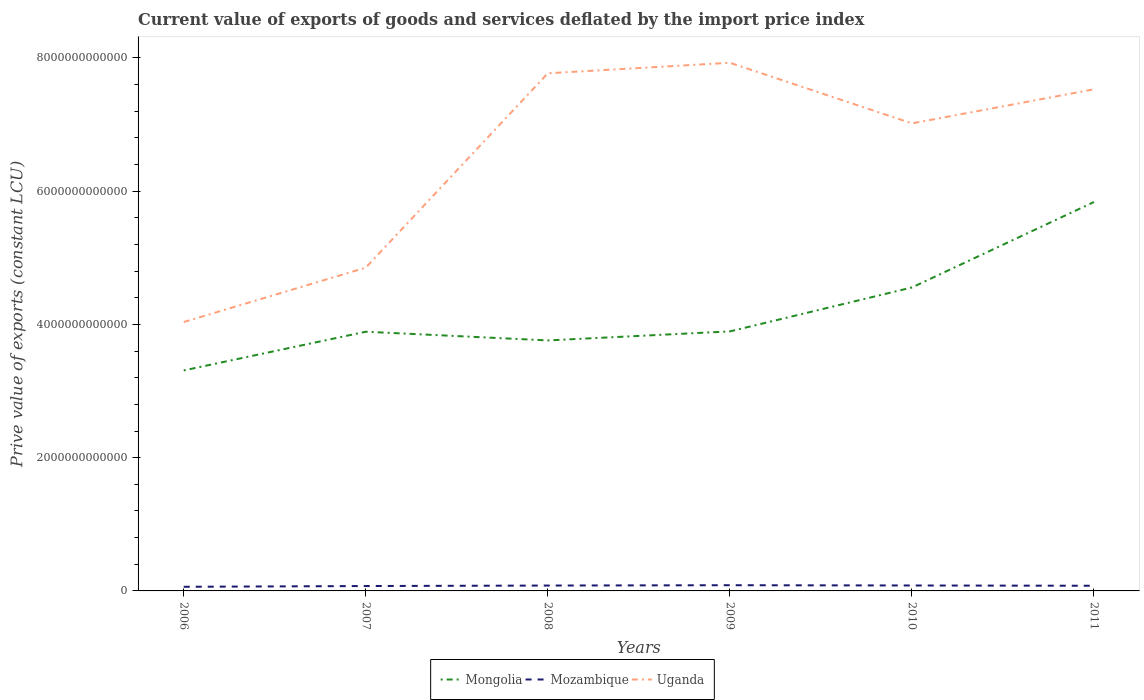Is the number of lines equal to the number of legend labels?
Make the answer very short. Yes. Across all years, what is the maximum prive value of exports in Mozambique?
Make the answer very short. 6.20e+1. What is the total prive value of exports in Mongolia in the graph?
Your answer should be compact. -1.25e+12. What is the difference between the highest and the second highest prive value of exports in Mozambique?
Offer a very short reply. 2.36e+1. What is the difference between the highest and the lowest prive value of exports in Uganda?
Your response must be concise. 4. How many years are there in the graph?
Your answer should be compact. 6. What is the difference between two consecutive major ticks on the Y-axis?
Your answer should be compact. 2.00e+12. How many legend labels are there?
Make the answer very short. 3. How are the legend labels stacked?
Ensure brevity in your answer.  Horizontal. What is the title of the graph?
Give a very brief answer. Current value of exports of goods and services deflated by the import price index. Does "Oman" appear as one of the legend labels in the graph?
Give a very brief answer. No. What is the label or title of the Y-axis?
Offer a terse response. Prive value of exports (constant LCU). What is the Prive value of exports (constant LCU) in Mongolia in 2006?
Make the answer very short. 3.31e+12. What is the Prive value of exports (constant LCU) in Mozambique in 2006?
Provide a succinct answer. 6.20e+1. What is the Prive value of exports (constant LCU) in Uganda in 2006?
Give a very brief answer. 4.04e+12. What is the Prive value of exports (constant LCU) of Mongolia in 2007?
Make the answer very short. 3.89e+12. What is the Prive value of exports (constant LCU) of Mozambique in 2007?
Your answer should be compact. 7.33e+1. What is the Prive value of exports (constant LCU) of Uganda in 2007?
Offer a terse response. 4.85e+12. What is the Prive value of exports (constant LCU) in Mongolia in 2008?
Give a very brief answer. 3.76e+12. What is the Prive value of exports (constant LCU) of Mozambique in 2008?
Make the answer very short. 8.07e+1. What is the Prive value of exports (constant LCU) in Uganda in 2008?
Your answer should be compact. 7.77e+12. What is the Prive value of exports (constant LCU) of Mongolia in 2009?
Your answer should be very brief. 3.89e+12. What is the Prive value of exports (constant LCU) in Mozambique in 2009?
Give a very brief answer. 8.57e+1. What is the Prive value of exports (constant LCU) of Uganda in 2009?
Provide a succinct answer. 7.93e+12. What is the Prive value of exports (constant LCU) in Mongolia in 2010?
Offer a terse response. 4.55e+12. What is the Prive value of exports (constant LCU) in Mozambique in 2010?
Keep it short and to the point. 8.16e+1. What is the Prive value of exports (constant LCU) of Uganda in 2010?
Make the answer very short. 7.02e+12. What is the Prive value of exports (constant LCU) of Mongolia in 2011?
Ensure brevity in your answer.  5.84e+12. What is the Prive value of exports (constant LCU) of Mozambique in 2011?
Provide a short and direct response. 7.76e+1. What is the Prive value of exports (constant LCU) of Uganda in 2011?
Your response must be concise. 7.53e+12. Across all years, what is the maximum Prive value of exports (constant LCU) of Mongolia?
Give a very brief answer. 5.84e+12. Across all years, what is the maximum Prive value of exports (constant LCU) in Mozambique?
Offer a very short reply. 8.57e+1. Across all years, what is the maximum Prive value of exports (constant LCU) of Uganda?
Keep it short and to the point. 7.93e+12. Across all years, what is the minimum Prive value of exports (constant LCU) in Mongolia?
Offer a very short reply. 3.31e+12. Across all years, what is the minimum Prive value of exports (constant LCU) in Mozambique?
Make the answer very short. 6.20e+1. Across all years, what is the minimum Prive value of exports (constant LCU) of Uganda?
Offer a terse response. 4.04e+12. What is the total Prive value of exports (constant LCU) of Mongolia in the graph?
Ensure brevity in your answer.  2.52e+13. What is the total Prive value of exports (constant LCU) in Mozambique in the graph?
Your response must be concise. 4.61e+11. What is the total Prive value of exports (constant LCU) in Uganda in the graph?
Your answer should be very brief. 3.91e+13. What is the difference between the Prive value of exports (constant LCU) in Mongolia in 2006 and that in 2007?
Keep it short and to the point. -5.81e+11. What is the difference between the Prive value of exports (constant LCU) of Mozambique in 2006 and that in 2007?
Offer a terse response. -1.13e+1. What is the difference between the Prive value of exports (constant LCU) in Uganda in 2006 and that in 2007?
Provide a short and direct response. -8.16e+11. What is the difference between the Prive value of exports (constant LCU) of Mongolia in 2006 and that in 2008?
Give a very brief answer. -4.50e+11. What is the difference between the Prive value of exports (constant LCU) of Mozambique in 2006 and that in 2008?
Make the answer very short. -1.87e+1. What is the difference between the Prive value of exports (constant LCU) of Uganda in 2006 and that in 2008?
Offer a terse response. -3.73e+12. What is the difference between the Prive value of exports (constant LCU) of Mongolia in 2006 and that in 2009?
Offer a terse response. -5.86e+11. What is the difference between the Prive value of exports (constant LCU) in Mozambique in 2006 and that in 2009?
Give a very brief answer. -2.36e+1. What is the difference between the Prive value of exports (constant LCU) in Uganda in 2006 and that in 2009?
Provide a succinct answer. -3.89e+12. What is the difference between the Prive value of exports (constant LCU) in Mongolia in 2006 and that in 2010?
Your answer should be compact. -1.25e+12. What is the difference between the Prive value of exports (constant LCU) in Mozambique in 2006 and that in 2010?
Make the answer very short. -1.96e+1. What is the difference between the Prive value of exports (constant LCU) of Uganda in 2006 and that in 2010?
Ensure brevity in your answer.  -2.98e+12. What is the difference between the Prive value of exports (constant LCU) of Mongolia in 2006 and that in 2011?
Your response must be concise. -2.53e+12. What is the difference between the Prive value of exports (constant LCU) in Mozambique in 2006 and that in 2011?
Give a very brief answer. -1.55e+1. What is the difference between the Prive value of exports (constant LCU) of Uganda in 2006 and that in 2011?
Ensure brevity in your answer.  -3.49e+12. What is the difference between the Prive value of exports (constant LCU) in Mongolia in 2007 and that in 2008?
Provide a succinct answer. 1.30e+11. What is the difference between the Prive value of exports (constant LCU) in Mozambique in 2007 and that in 2008?
Your answer should be very brief. -7.39e+09. What is the difference between the Prive value of exports (constant LCU) of Uganda in 2007 and that in 2008?
Your answer should be very brief. -2.92e+12. What is the difference between the Prive value of exports (constant LCU) of Mongolia in 2007 and that in 2009?
Provide a succinct answer. -4.92e+09. What is the difference between the Prive value of exports (constant LCU) in Mozambique in 2007 and that in 2009?
Provide a short and direct response. -1.24e+1. What is the difference between the Prive value of exports (constant LCU) of Uganda in 2007 and that in 2009?
Provide a succinct answer. -3.07e+12. What is the difference between the Prive value of exports (constant LCU) in Mongolia in 2007 and that in 2010?
Your answer should be very brief. -6.64e+11. What is the difference between the Prive value of exports (constant LCU) of Mozambique in 2007 and that in 2010?
Give a very brief answer. -8.29e+09. What is the difference between the Prive value of exports (constant LCU) in Uganda in 2007 and that in 2010?
Ensure brevity in your answer.  -2.17e+12. What is the difference between the Prive value of exports (constant LCU) in Mongolia in 2007 and that in 2011?
Give a very brief answer. -1.95e+12. What is the difference between the Prive value of exports (constant LCU) in Mozambique in 2007 and that in 2011?
Ensure brevity in your answer.  -4.24e+09. What is the difference between the Prive value of exports (constant LCU) of Uganda in 2007 and that in 2011?
Make the answer very short. -2.68e+12. What is the difference between the Prive value of exports (constant LCU) of Mongolia in 2008 and that in 2009?
Provide a succinct answer. -1.35e+11. What is the difference between the Prive value of exports (constant LCU) in Mozambique in 2008 and that in 2009?
Keep it short and to the point. -4.97e+09. What is the difference between the Prive value of exports (constant LCU) of Uganda in 2008 and that in 2009?
Make the answer very short. -1.58e+11. What is the difference between the Prive value of exports (constant LCU) in Mongolia in 2008 and that in 2010?
Provide a succinct answer. -7.95e+11. What is the difference between the Prive value of exports (constant LCU) of Mozambique in 2008 and that in 2010?
Your response must be concise. -9.01e+08. What is the difference between the Prive value of exports (constant LCU) in Uganda in 2008 and that in 2010?
Provide a succinct answer. 7.52e+11. What is the difference between the Prive value of exports (constant LCU) in Mongolia in 2008 and that in 2011?
Your response must be concise. -2.08e+12. What is the difference between the Prive value of exports (constant LCU) in Mozambique in 2008 and that in 2011?
Keep it short and to the point. 3.14e+09. What is the difference between the Prive value of exports (constant LCU) of Uganda in 2008 and that in 2011?
Give a very brief answer. 2.40e+11. What is the difference between the Prive value of exports (constant LCU) of Mongolia in 2009 and that in 2010?
Your response must be concise. -6.59e+11. What is the difference between the Prive value of exports (constant LCU) in Mozambique in 2009 and that in 2010?
Your response must be concise. 4.07e+09. What is the difference between the Prive value of exports (constant LCU) of Uganda in 2009 and that in 2010?
Provide a succinct answer. 9.10e+11. What is the difference between the Prive value of exports (constant LCU) of Mongolia in 2009 and that in 2011?
Offer a terse response. -1.94e+12. What is the difference between the Prive value of exports (constant LCU) in Mozambique in 2009 and that in 2011?
Your answer should be compact. 8.12e+09. What is the difference between the Prive value of exports (constant LCU) of Uganda in 2009 and that in 2011?
Your response must be concise. 3.98e+11. What is the difference between the Prive value of exports (constant LCU) of Mongolia in 2010 and that in 2011?
Provide a succinct answer. -1.28e+12. What is the difference between the Prive value of exports (constant LCU) in Mozambique in 2010 and that in 2011?
Keep it short and to the point. 4.04e+09. What is the difference between the Prive value of exports (constant LCU) of Uganda in 2010 and that in 2011?
Make the answer very short. -5.12e+11. What is the difference between the Prive value of exports (constant LCU) of Mongolia in 2006 and the Prive value of exports (constant LCU) of Mozambique in 2007?
Keep it short and to the point. 3.24e+12. What is the difference between the Prive value of exports (constant LCU) in Mongolia in 2006 and the Prive value of exports (constant LCU) in Uganda in 2007?
Make the answer very short. -1.54e+12. What is the difference between the Prive value of exports (constant LCU) in Mozambique in 2006 and the Prive value of exports (constant LCU) in Uganda in 2007?
Make the answer very short. -4.79e+12. What is the difference between the Prive value of exports (constant LCU) in Mongolia in 2006 and the Prive value of exports (constant LCU) in Mozambique in 2008?
Offer a very short reply. 3.23e+12. What is the difference between the Prive value of exports (constant LCU) in Mongolia in 2006 and the Prive value of exports (constant LCU) in Uganda in 2008?
Your answer should be very brief. -4.46e+12. What is the difference between the Prive value of exports (constant LCU) in Mozambique in 2006 and the Prive value of exports (constant LCU) in Uganda in 2008?
Your answer should be very brief. -7.71e+12. What is the difference between the Prive value of exports (constant LCU) in Mongolia in 2006 and the Prive value of exports (constant LCU) in Mozambique in 2009?
Make the answer very short. 3.22e+12. What is the difference between the Prive value of exports (constant LCU) in Mongolia in 2006 and the Prive value of exports (constant LCU) in Uganda in 2009?
Ensure brevity in your answer.  -4.62e+12. What is the difference between the Prive value of exports (constant LCU) in Mozambique in 2006 and the Prive value of exports (constant LCU) in Uganda in 2009?
Provide a short and direct response. -7.86e+12. What is the difference between the Prive value of exports (constant LCU) in Mongolia in 2006 and the Prive value of exports (constant LCU) in Mozambique in 2010?
Ensure brevity in your answer.  3.23e+12. What is the difference between the Prive value of exports (constant LCU) of Mongolia in 2006 and the Prive value of exports (constant LCU) of Uganda in 2010?
Keep it short and to the point. -3.71e+12. What is the difference between the Prive value of exports (constant LCU) in Mozambique in 2006 and the Prive value of exports (constant LCU) in Uganda in 2010?
Your answer should be very brief. -6.95e+12. What is the difference between the Prive value of exports (constant LCU) in Mongolia in 2006 and the Prive value of exports (constant LCU) in Mozambique in 2011?
Offer a terse response. 3.23e+12. What is the difference between the Prive value of exports (constant LCU) of Mongolia in 2006 and the Prive value of exports (constant LCU) of Uganda in 2011?
Your answer should be compact. -4.22e+12. What is the difference between the Prive value of exports (constant LCU) in Mozambique in 2006 and the Prive value of exports (constant LCU) in Uganda in 2011?
Provide a succinct answer. -7.47e+12. What is the difference between the Prive value of exports (constant LCU) in Mongolia in 2007 and the Prive value of exports (constant LCU) in Mozambique in 2008?
Give a very brief answer. 3.81e+12. What is the difference between the Prive value of exports (constant LCU) in Mongolia in 2007 and the Prive value of exports (constant LCU) in Uganda in 2008?
Provide a short and direct response. -3.88e+12. What is the difference between the Prive value of exports (constant LCU) in Mozambique in 2007 and the Prive value of exports (constant LCU) in Uganda in 2008?
Provide a short and direct response. -7.70e+12. What is the difference between the Prive value of exports (constant LCU) of Mongolia in 2007 and the Prive value of exports (constant LCU) of Mozambique in 2009?
Offer a terse response. 3.80e+12. What is the difference between the Prive value of exports (constant LCU) in Mongolia in 2007 and the Prive value of exports (constant LCU) in Uganda in 2009?
Make the answer very short. -4.04e+12. What is the difference between the Prive value of exports (constant LCU) of Mozambique in 2007 and the Prive value of exports (constant LCU) of Uganda in 2009?
Ensure brevity in your answer.  -7.85e+12. What is the difference between the Prive value of exports (constant LCU) of Mongolia in 2007 and the Prive value of exports (constant LCU) of Mozambique in 2010?
Give a very brief answer. 3.81e+12. What is the difference between the Prive value of exports (constant LCU) in Mongolia in 2007 and the Prive value of exports (constant LCU) in Uganda in 2010?
Your answer should be compact. -3.13e+12. What is the difference between the Prive value of exports (constant LCU) of Mozambique in 2007 and the Prive value of exports (constant LCU) of Uganda in 2010?
Your answer should be very brief. -6.94e+12. What is the difference between the Prive value of exports (constant LCU) in Mongolia in 2007 and the Prive value of exports (constant LCU) in Mozambique in 2011?
Offer a very short reply. 3.81e+12. What is the difference between the Prive value of exports (constant LCU) in Mongolia in 2007 and the Prive value of exports (constant LCU) in Uganda in 2011?
Provide a succinct answer. -3.64e+12. What is the difference between the Prive value of exports (constant LCU) of Mozambique in 2007 and the Prive value of exports (constant LCU) of Uganda in 2011?
Ensure brevity in your answer.  -7.45e+12. What is the difference between the Prive value of exports (constant LCU) in Mongolia in 2008 and the Prive value of exports (constant LCU) in Mozambique in 2009?
Your response must be concise. 3.67e+12. What is the difference between the Prive value of exports (constant LCU) of Mongolia in 2008 and the Prive value of exports (constant LCU) of Uganda in 2009?
Your answer should be compact. -4.17e+12. What is the difference between the Prive value of exports (constant LCU) in Mozambique in 2008 and the Prive value of exports (constant LCU) in Uganda in 2009?
Your response must be concise. -7.85e+12. What is the difference between the Prive value of exports (constant LCU) in Mongolia in 2008 and the Prive value of exports (constant LCU) in Mozambique in 2010?
Your answer should be very brief. 3.68e+12. What is the difference between the Prive value of exports (constant LCU) in Mongolia in 2008 and the Prive value of exports (constant LCU) in Uganda in 2010?
Provide a short and direct response. -3.26e+12. What is the difference between the Prive value of exports (constant LCU) of Mozambique in 2008 and the Prive value of exports (constant LCU) of Uganda in 2010?
Offer a terse response. -6.94e+12. What is the difference between the Prive value of exports (constant LCU) in Mongolia in 2008 and the Prive value of exports (constant LCU) in Mozambique in 2011?
Give a very brief answer. 3.68e+12. What is the difference between the Prive value of exports (constant LCU) in Mongolia in 2008 and the Prive value of exports (constant LCU) in Uganda in 2011?
Your response must be concise. -3.77e+12. What is the difference between the Prive value of exports (constant LCU) of Mozambique in 2008 and the Prive value of exports (constant LCU) of Uganda in 2011?
Offer a terse response. -7.45e+12. What is the difference between the Prive value of exports (constant LCU) of Mongolia in 2009 and the Prive value of exports (constant LCU) of Mozambique in 2010?
Give a very brief answer. 3.81e+12. What is the difference between the Prive value of exports (constant LCU) of Mongolia in 2009 and the Prive value of exports (constant LCU) of Uganda in 2010?
Your response must be concise. -3.12e+12. What is the difference between the Prive value of exports (constant LCU) in Mozambique in 2009 and the Prive value of exports (constant LCU) in Uganda in 2010?
Keep it short and to the point. -6.93e+12. What is the difference between the Prive value of exports (constant LCU) of Mongolia in 2009 and the Prive value of exports (constant LCU) of Mozambique in 2011?
Make the answer very short. 3.82e+12. What is the difference between the Prive value of exports (constant LCU) in Mongolia in 2009 and the Prive value of exports (constant LCU) in Uganda in 2011?
Offer a terse response. -3.63e+12. What is the difference between the Prive value of exports (constant LCU) of Mozambique in 2009 and the Prive value of exports (constant LCU) of Uganda in 2011?
Keep it short and to the point. -7.44e+12. What is the difference between the Prive value of exports (constant LCU) of Mongolia in 2010 and the Prive value of exports (constant LCU) of Mozambique in 2011?
Offer a terse response. 4.48e+12. What is the difference between the Prive value of exports (constant LCU) in Mongolia in 2010 and the Prive value of exports (constant LCU) in Uganda in 2011?
Your response must be concise. -2.97e+12. What is the difference between the Prive value of exports (constant LCU) of Mozambique in 2010 and the Prive value of exports (constant LCU) of Uganda in 2011?
Your answer should be compact. -7.45e+12. What is the average Prive value of exports (constant LCU) in Mongolia per year?
Give a very brief answer. 4.21e+12. What is the average Prive value of exports (constant LCU) of Mozambique per year?
Make the answer very short. 7.68e+1. What is the average Prive value of exports (constant LCU) of Uganda per year?
Ensure brevity in your answer.  6.52e+12. In the year 2006, what is the difference between the Prive value of exports (constant LCU) of Mongolia and Prive value of exports (constant LCU) of Mozambique?
Your answer should be very brief. 3.25e+12. In the year 2006, what is the difference between the Prive value of exports (constant LCU) in Mongolia and Prive value of exports (constant LCU) in Uganda?
Keep it short and to the point. -7.27e+11. In the year 2006, what is the difference between the Prive value of exports (constant LCU) of Mozambique and Prive value of exports (constant LCU) of Uganda?
Give a very brief answer. -3.97e+12. In the year 2007, what is the difference between the Prive value of exports (constant LCU) of Mongolia and Prive value of exports (constant LCU) of Mozambique?
Your answer should be compact. 3.82e+12. In the year 2007, what is the difference between the Prive value of exports (constant LCU) in Mongolia and Prive value of exports (constant LCU) in Uganda?
Offer a very short reply. -9.62e+11. In the year 2007, what is the difference between the Prive value of exports (constant LCU) in Mozambique and Prive value of exports (constant LCU) in Uganda?
Provide a succinct answer. -4.78e+12. In the year 2008, what is the difference between the Prive value of exports (constant LCU) in Mongolia and Prive value of exports (constant LCU) in Mozambique?
Ensure brevity in your answer.  3.68e+12. In the year 2008, what is the difference between the Prive value of exports (constant LCU) of Mongolia and Prive value of exports (constant LCU) of Uganda?
Your response must be concise. -4.01e+12. In the year 2008, what is the difference between the Prive value of exports (constant LCU) in Mozambique and Prive value of exports (constant LCU) in Uganda?
Provide a succinct answer. -7.69e+12. In the year 2009, what is the difference between the Prive value of exports (constant LCU) in Mongolia and Prive value of exports (constant LCU) in Mozambique?
Ensure brevity in your answer.  3.81e+12. In the year 2009, what is the difference between the Prive value of exports (constant LCU) in Mongolia and Prive value of exports (constant LCU) in Uganda?
Provide a succinct answer. -4.03e+12. In the year 2009, what is the difference between the Prive value of exports (constant LCU) of Mozambique and Prive value of exports (constant LCU) of Uganda?
Ensure brevity in your answer.  -7.84e+12. In the year 2010, what is the difference between the Prive value of exports (constant LCU) of Mongolia and Prive value of exports (constant LCU) of Mozambique?
Your answer should be compact. 4.47e+12. In the year 2010, what is the difference between the Prive value of exports (constant LCU) of Mongolia and Prive value of exports (constant LCU) of Uganda?
Your response must be concise. -2.46e+12. In the year 2010, what is the difference between the Prive value of exports (constant LCU) in Mozambique and Prive value of exports (constant LCU) in Uganda?
Provide a succinct answer. -6.93e+12. In the year 2011, what is the difference between the Prive value of exports (constant LCU) in Mongolia and Prive value of exports (constant LCU) in Mozambique?
Provide a short and direct response. 5.76e+12. In the year 2011, what is the difference between the Prive value of exports (constant LCU) in Mongolia and Prive value of exports (constant LCU) in Uganda?
Provide a succinct answer. -1.69e+12. In the year 2011, what is the difference between the Prive value of exports (constant LCU) of Mozambique and Prive value of exports (constant LCU) of Uganda?
Your answer should be very brief. -7.45e+12. What is the ratio of the Prive value of exports (constant LCU) of Mongolia in 2006 to that in 2007?
Ensure brevity in your answer.  0.85. What is the ratio of the Prive value of exports (constant LCU) in Mozambique in 2006 to that in 2007?
Offer a very short reply. 0.85. What is the ratio of the Prive value of exports (constant LCU) of Uganda in 2006 to that in 2007?
Your response must be concise. 0.83. What is the ratio of the Prive value of exports (constant LCU) of Mongolia in 2006 to that in 2008?
Your response must be concise. 0.88. What is the ratio of the Prive value of exports (constant LCU) in Mozambique in 2006 to that in 2008?
Your answer should be very brief. 0.77. What is the ratio of the Prive value of exports (constant LCU) of Uganda in 2006 to that in 2008?
Offer a terse response. 0.52. What is the ratio of the Prive value of exports (constant LCU) in Mongolia in 2006 to that in 2009?
Offer a very short reply. 0.85. What is the ratio of the Prive value of exports (constant LCU) of Mozambique in 2006 to that in 2009?
Ensure brevity in your answer.  0.72. What is the ratio of the Prive value of exports (constant LCU) of Uganda in 2006 to that in 2009?
Keep it short and to the point. 0.51. What is the ratio of the Prive value of exports (constant LCU) in Mongolia in 2006 to that in 2010?
Offer a terse response. 0.73. What is the ratio of the Prive value of exports (constant LCU) of Mozambique in 2006 to that in 2010?
Your answer should be very brief. 0.76. What is the ratio of the Prive value of exports (constant LCU) of Uganda in 2006 to that in 2010?
Keep it short and to the point. 0.58. What is the ratio of the Prive value of exports (constant LCU) in Mongolia in 2006 to that in 2011?
Give a very brief answer. 0.57. What is the ratio of the Prive value of exports (constant LCU) in Mozambique in 2006 to that in 2011?
Your answer should be very brief. 0.8. What is the ratio of the Prive value of exports (constant LCU) of Uganda in 2006 to that in 2011?
Offer a terse response. 0.54. What is the ratio of the Prive value of exports (constant LCU) of Mongolia in 2007 to that in 2008?
Keep it short and to the point. 1.03. What is the ratio of the Prive value of exports (constant LCU) of Mozambique in 2007 to that in 2008?
Give a very brief answer. 0.91. What is the ratio of the Prive value of exports (constant LCU) of Uganda in 2007 to that in 2008?
Make the answer very short. 0.62. What is the ratio of the Prive value of exports (constant LCU) in Mongolia in 2007 to that in 2009?
Ensure brevity in your answer.  1. What is the ratio of the Prive value of exports (constant LCU) of Mozambique in 2007 to that in 2009?
Give a very brief answer. 0.86. What is the ratio of the Prive value of exports (constant LCU) in Uganda in 2007 to that in 2009?
Provide a short and direct response. 0.61. What is the ratio of the Prive value of exports (constant LCU) in Mongolia in 2007 to that in 2010?
Keep it short and to the point. 0.85. What is the ratio of the Prive value of exports (constant LCU) in Mozambique in 2007 to that in 2010?
Make the answer very short. 0.9. What is the ratio of the Prive value of exports (constant LCU) of Uganda in 2007 to that in 2010?
Keep it short and to the point. 0.69. What is the ratio of the Prive value of exports (constant LCU) of Mongolia in 2007 to that in 2011?
Your response must be concise. 0.67. What is the ratio of the Prive value of exports (constant LCU) of Mozambique in 2007 to that in 2011?
Your response must be concise. 0.95. What is the ratio of the Prive value of exports (constant LCU) of Uganda in 2007 to that in 2011?
Your answer should be compact. 0.64. What is the ratio of the Prive value of exports (constant LCU) in Mongolia in 2008 to that in 2009?
Give a very brief answer. 0.97. What is the ratio of the Prive value of exports (constant LCU) of Mozambique in 2008 to that in 2009?
Provide a succinct answer. 0.94. What is the ratio of the Prive value of exports (constant LCU) in Uganda in 2008 to that in 2009?
Offer a very short reply. 0.98. What is the ratio of the Prive value of exports (constant LCU) in Mongolia in 2008 to that in 2010?
Offer a terse response. 0.83. What is the ratio of the Prive value of exports (constant LCU) in Uganda in 2008 to that in 2010?
Provide a succinct answer. 1.11. What is the ratio of the Prive value of exports (constant LCU) of Mongolia in 2008 to that in 2011?
Ensure brevity in your answer.  0.64. What is the ratio of the Prive value of exports (constant LCU) in Mozambique in 2008 to that in 2011?
Ensure brevity in your answer.  1.04. What is the ratio of the Prive value of exports (constant LCU) in Uganda in 2008 to that in 2011?
Offer a terse response. 1.03. What is the ratio of the Prive value of exports (constant LCU) in Mongolia in 2009 to that in 2010?
Your answer should be very brief. 0.86. What is the ratio of the Prive value of exports (constant LCU) in Mozambique in 2009 to that in 2010?
Your answer should be very brief. 1.05. What is the ratio of the Prive value of exports (constant LCU) in Uganda in 2009 to that in 2010?
Your answer should be compact. 1.13. What is the ratio of the Prive value of exports (constant LCU) of Mongolia in 2009 to that in 2011?
Your response must be concise. 0.67. What is the ratio of the Prive value of exports (constant LCU) in Mozambique in 2009 to that in 2011?
Give a very brief answer. 1.1. What is the ratio of the Prive value of exports (constant LCU) in Uganda in 2009 to that in 2011?
Your response must be concise. 1.05. What is the ratio of the Prive value of exports (constant LCU) in Mongolia in 2010 to that in 2011?
Keep it short and to the point. 0.78. What is the ratio of the Prive value of exports (constant LCU) in Mozambique in 2010 to that in 2011?
Provide a short and direct response. 1.05. What is the ratio of the Prive value of exports (constant LCU) in Uganda in 2010 to that in 2011?
Your answer should be compact. 0.93. What is the difference between the highest and the second highest Prive value of exports (constant LCU) of Mongolia?
Ensure brevity in your answer.  1.28e+12. What is the difference between the highest and the second highest Prive value of exports (constant LCU) of Mozambique?
Make the answer very short. 4.07e+09. What is the difference between the highest and the second highest Prive value of exports (constant LCU) in Uganda?
Offer a terse response. 1.58e+11. What is the difference between the highest and the lowest Prive value of exports (constant LCU) in Mongolia?
Provide a succinct answer. 2.53e+12. What is the difference between the highest and the lowest Prive value of exports (constant LCU) in Mozambique?
Offer a terse response. 2.36e+1. What is the difference between the highest and the lowest Prive value of exports (constant LCU) of Uganda?
Your answer should be very brief. 3.89e+12. 